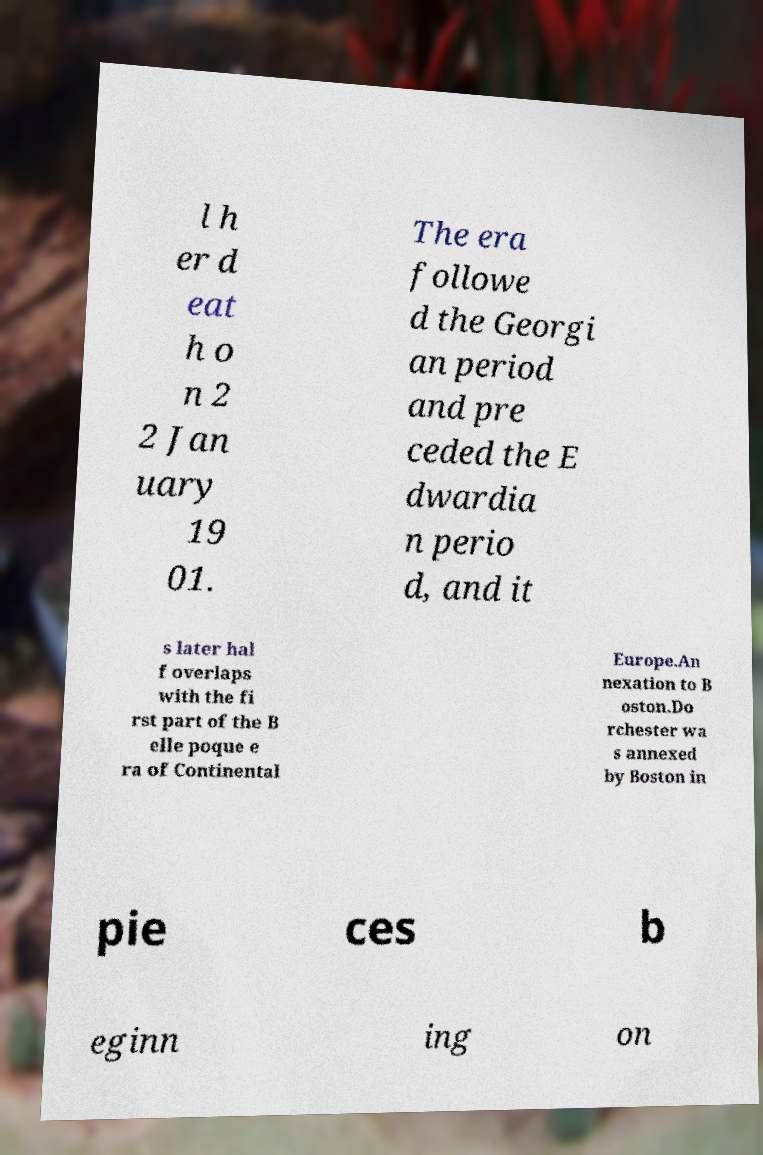Please read and relay the text visible in this image. What does it say? l h er d eat h o n 2 2 Jan uary 19 01. The era followe d the Georgi an period and pre ceded the E dwardia n perio d, and it s later hal f overlaps with the fi rst part of the B elle poque e ra of Continental Europe.An nexation to B oston.Do rchester wa s annexed by Boston in pie ces b eginn ing on 